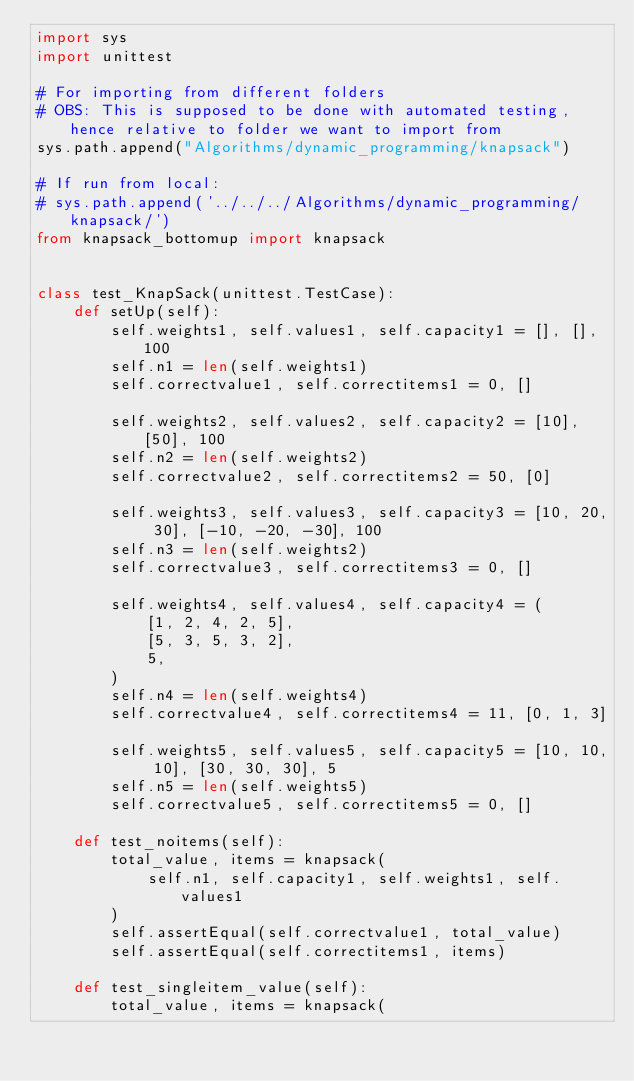<code> <loc_0><loc_0><loc_500><loc_500><_Python_>import sys
import unittest

# For importing from different folders
# OBS: This is supposed to be done with automated testing, hence relative to folder we want to import from
sys.path.append("Algorithms/dynamic_programming/knapsack")

# If run from local:
# sys.path.append('../../../Algorithms/dynamic_programming/knapsack/')
from knapsack_bottomup import knapsack


class test_KnapSack(unittest.TestCase):
    def setUp(self):
        self.weights1, self.values1, self.capacity1 = [], [], 100
        self.n1 = len(self.weights1)
        self.correctvalue1, self.correctitems1 = 0, []

        self.weights2, self.values2, self.capacity2 = [10], [50], 100
        self.n2 = len(self.weights2)
        self.correctvalue2, self.correctitems2 = 50, [0]

        self.weights3, self.values3, self.capacity3 = [10, 20, 30], [-10, -20, -30], 100
        self.n3 = len(self.weights2)
        self.correctvalue3, self.correctitems3 = 0, []

        self.weights4, self.values4, self.capacity4 = (
            [1, 2, 4, 2, 5],
            [5, 3, 5, 3, 2],
            5,
        )
        self.n4 = len(self.weights4)
        self.correctvalue4, self.correctitems4 = 11, [0, 1, 3]

        self.weights5, self.values5, self.capacity5 = [10, 10, 10], [30, 30, 30], 5
        self.n5 = len(self.weights5)
        self.correctvalue5, self.correctitems5 = 0, []

    def test_noitems(self):
        total_value, items = knapsack(
            self.n1, self.capacity1, self.weights1, self.values1
        )
        self.assertEqual(self.correctvalue1, total_value)
        self.assertEqual(self.correctitems1, items)

    def test_singleitem_value(self):
        total_value, items = knapsack(</code> 